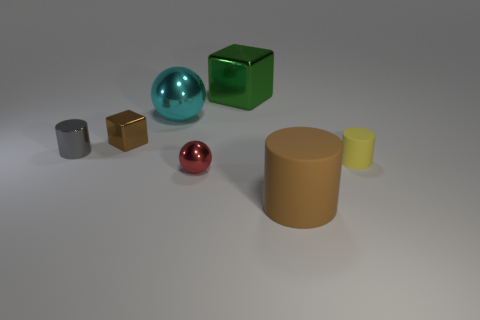Subtract all tiny matte cylinders. How many cylinders are left? 2 Subtract 1 cylinders. How many cylinders are left? 2 Add 2 tiny matte cylinders. How many objects exist? 9 Subtract all cubes. How many objects are left? 5 Add 1 cyan objects. How many cyan objects exist? 2 Subtract 1 red spheres. How many objects are left? 6 Subtract all cyan balls. Subtract all tiny red metallic objects. How many objects are left? 5 Add 1 big brown rubber cylinders. How many big brown rubber cylinders are left? 2 